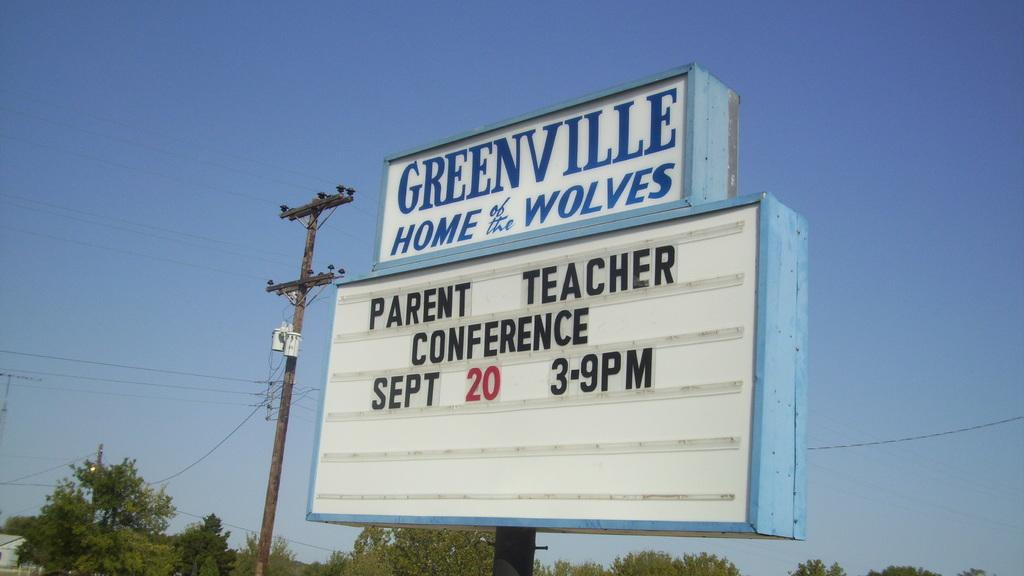<image>
Relay a brief, clear account of the picture shown. A school bulletin board reading Greenville, Home of the Wolves 